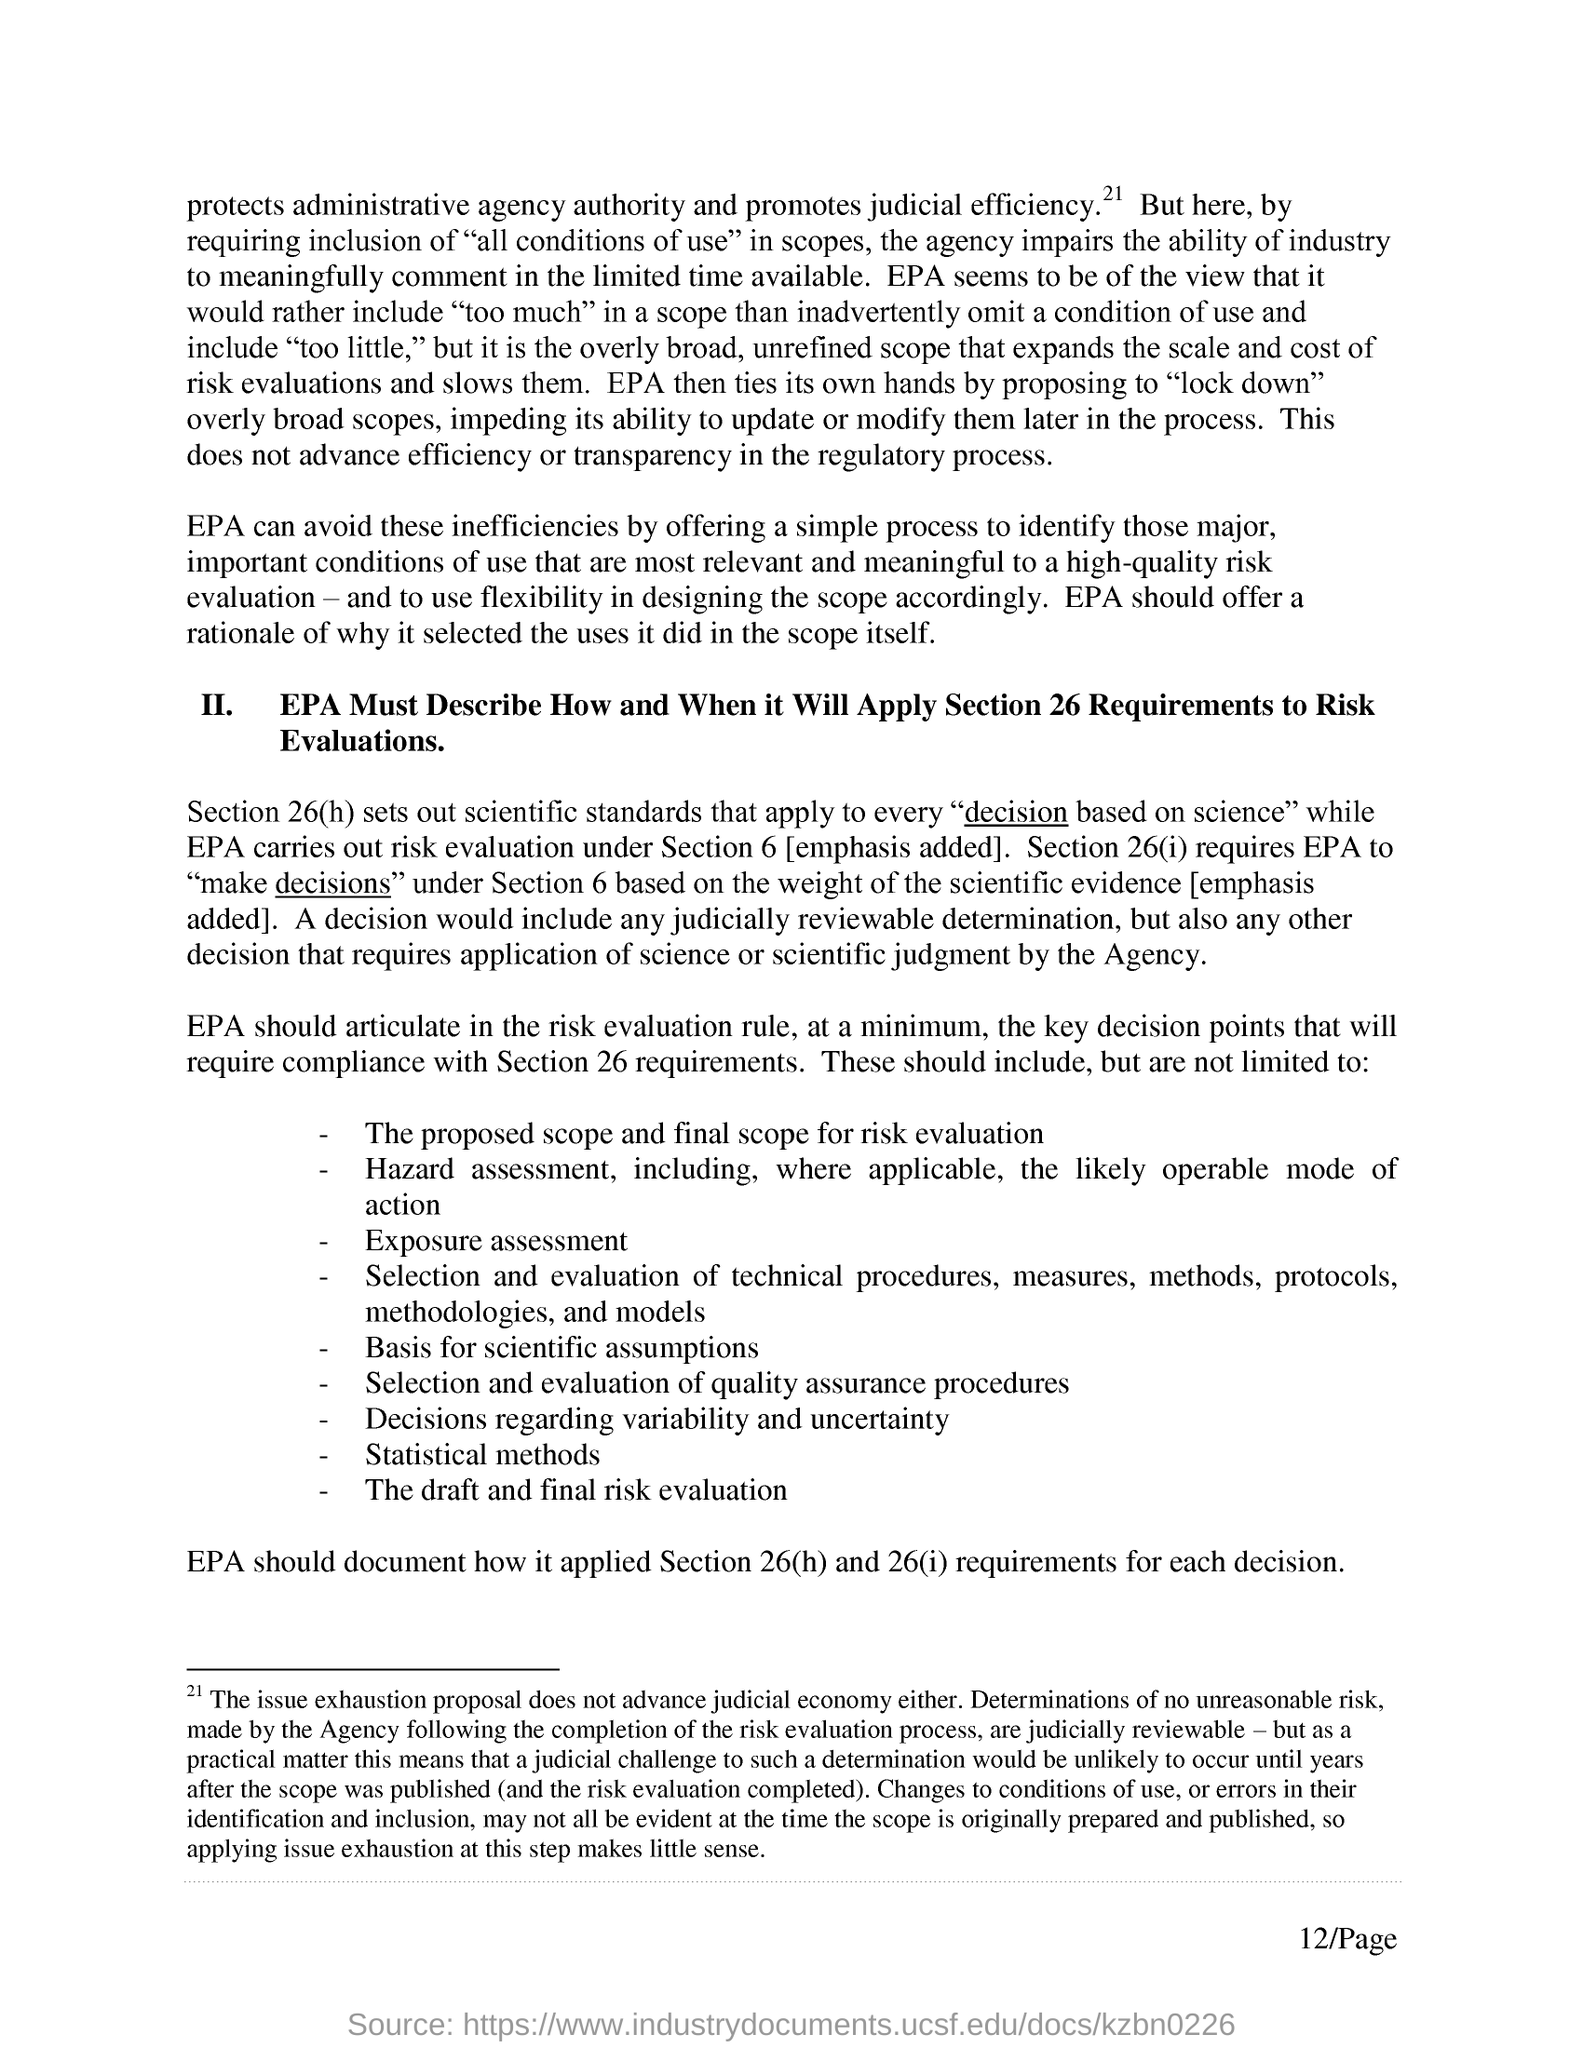Outline some significant characteristics in this image. Section 26(h) sets out scientific standards that apply to every decision based on science. EPA conducts risk evaluations under Section 6 of the Lautenberg Chemical Safety Act. 